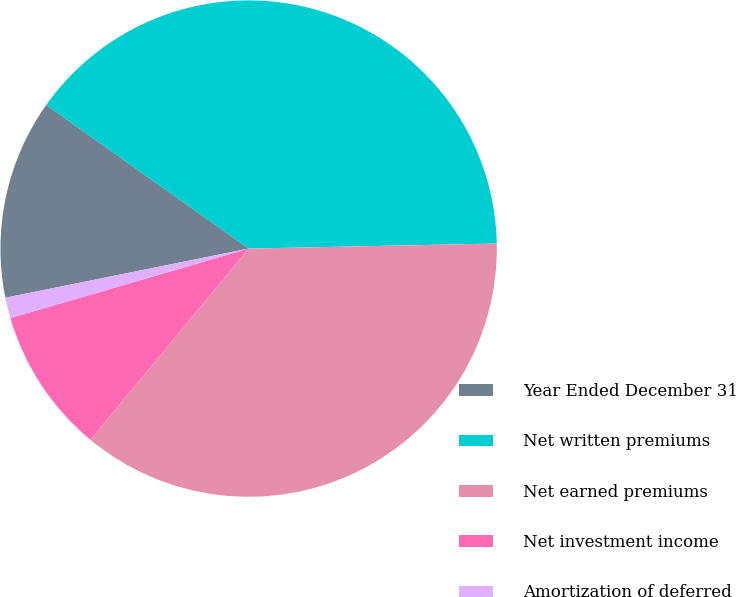<chart> <loc_0><loc_0><loc_500><loc_500><pie_chart><fcel>Year Ended December 31<fcel>Net written premiums<fcel>Net earned premiums<fcel>Net investment income<fcel>Amortization of deferred<nl><fcel>13.0%<fcel>39.85%<fcel>36.33%<fcel>9.48%<fcel>1.34%<nl></chart> 